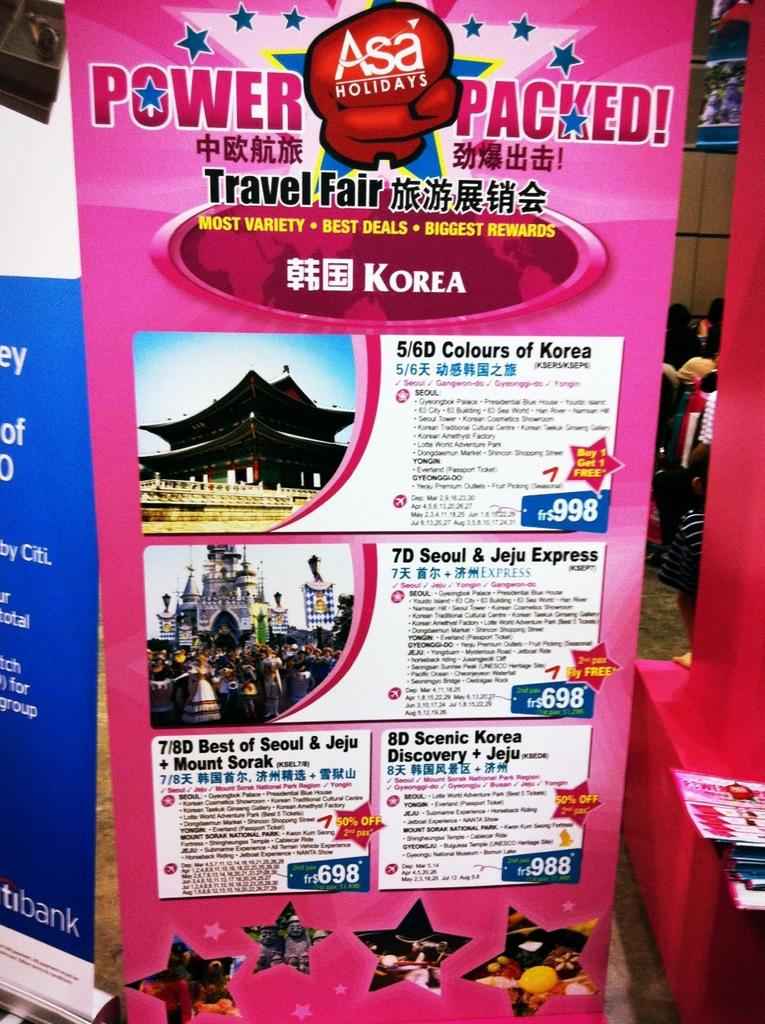<image>
Offer a succinct explanation of the picture presented. Power Packed Travel Fair advertises for best deals in Korea. 